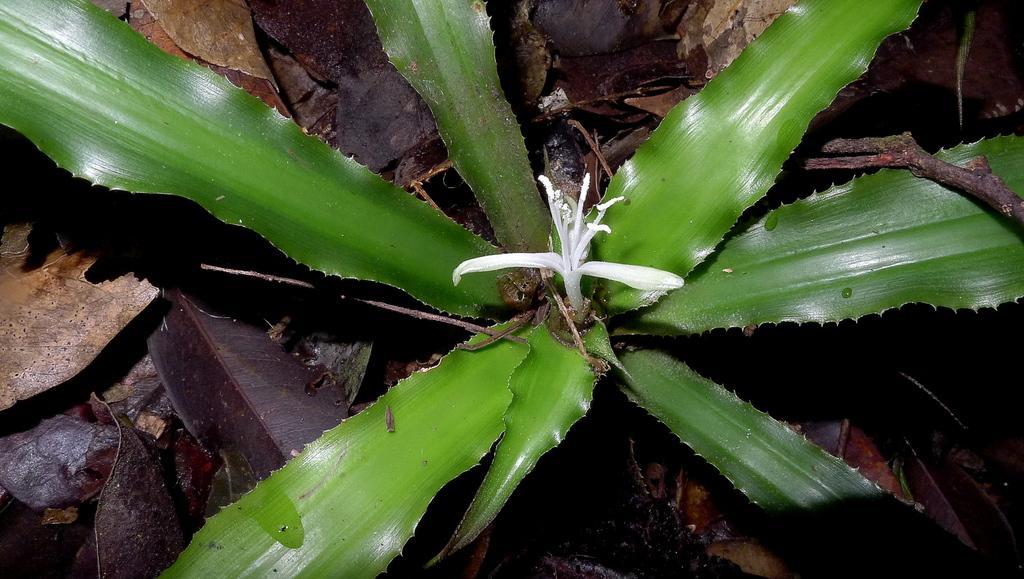Could you give a brief overview of what you see in this image? In this image there is a plant and there are dry leaves. 